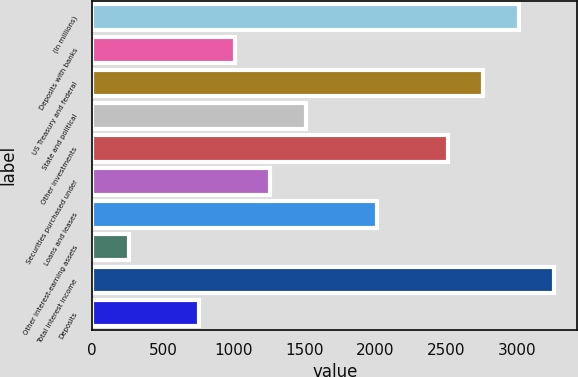Convert chart to OTSL. <chart><loc_0><loc_0><loc_500><loc_500><bar_chart><fcel>(In millions)<fcel>Deposits with banks<fcel>US Treasury and federal<fcel>State and political<fcel>Other investments<fcel>Securities purchased under<fcel>Loans and leases<fcel>Other interest-earning assets<fcel>Total interest income<fcel>Deposits<nl><fcel>3013<fcel>1009<fcel>2762.5<fcel>1510<fcel>2512<fcel>1259.5<fcel>2011<fcel>257.5<fcel>3263.5<fcel>758.5<nl></chart> 